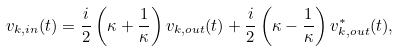<formula> <loc_0><loc_0><loc_500><loc_500>v _ { { k } , i n } ( t ) = \frac { i } { 2 } \left ( \kappa + \frac { 1 } { \kappa } \right ) v _ { { k } , o u t } ( t ) + \frac { i } { 2 } \left ( \kappa - \frac { 1 } { \kappa } \right ) v ^ { * } _ { { k } , o u t } ( t ) ,</formula> 